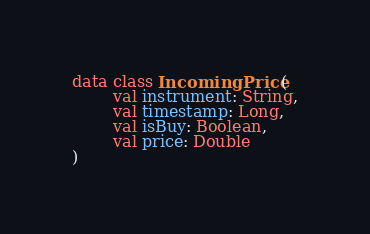Convert code to text. <code><loc_0><loc_0><loc_500><loc_500><_Kotlin_>data class IncomingPrice (
        val instrument: String,
        val timestamp: Long,
        val isBuy: Boolean,
        val price: Double
)</code> 